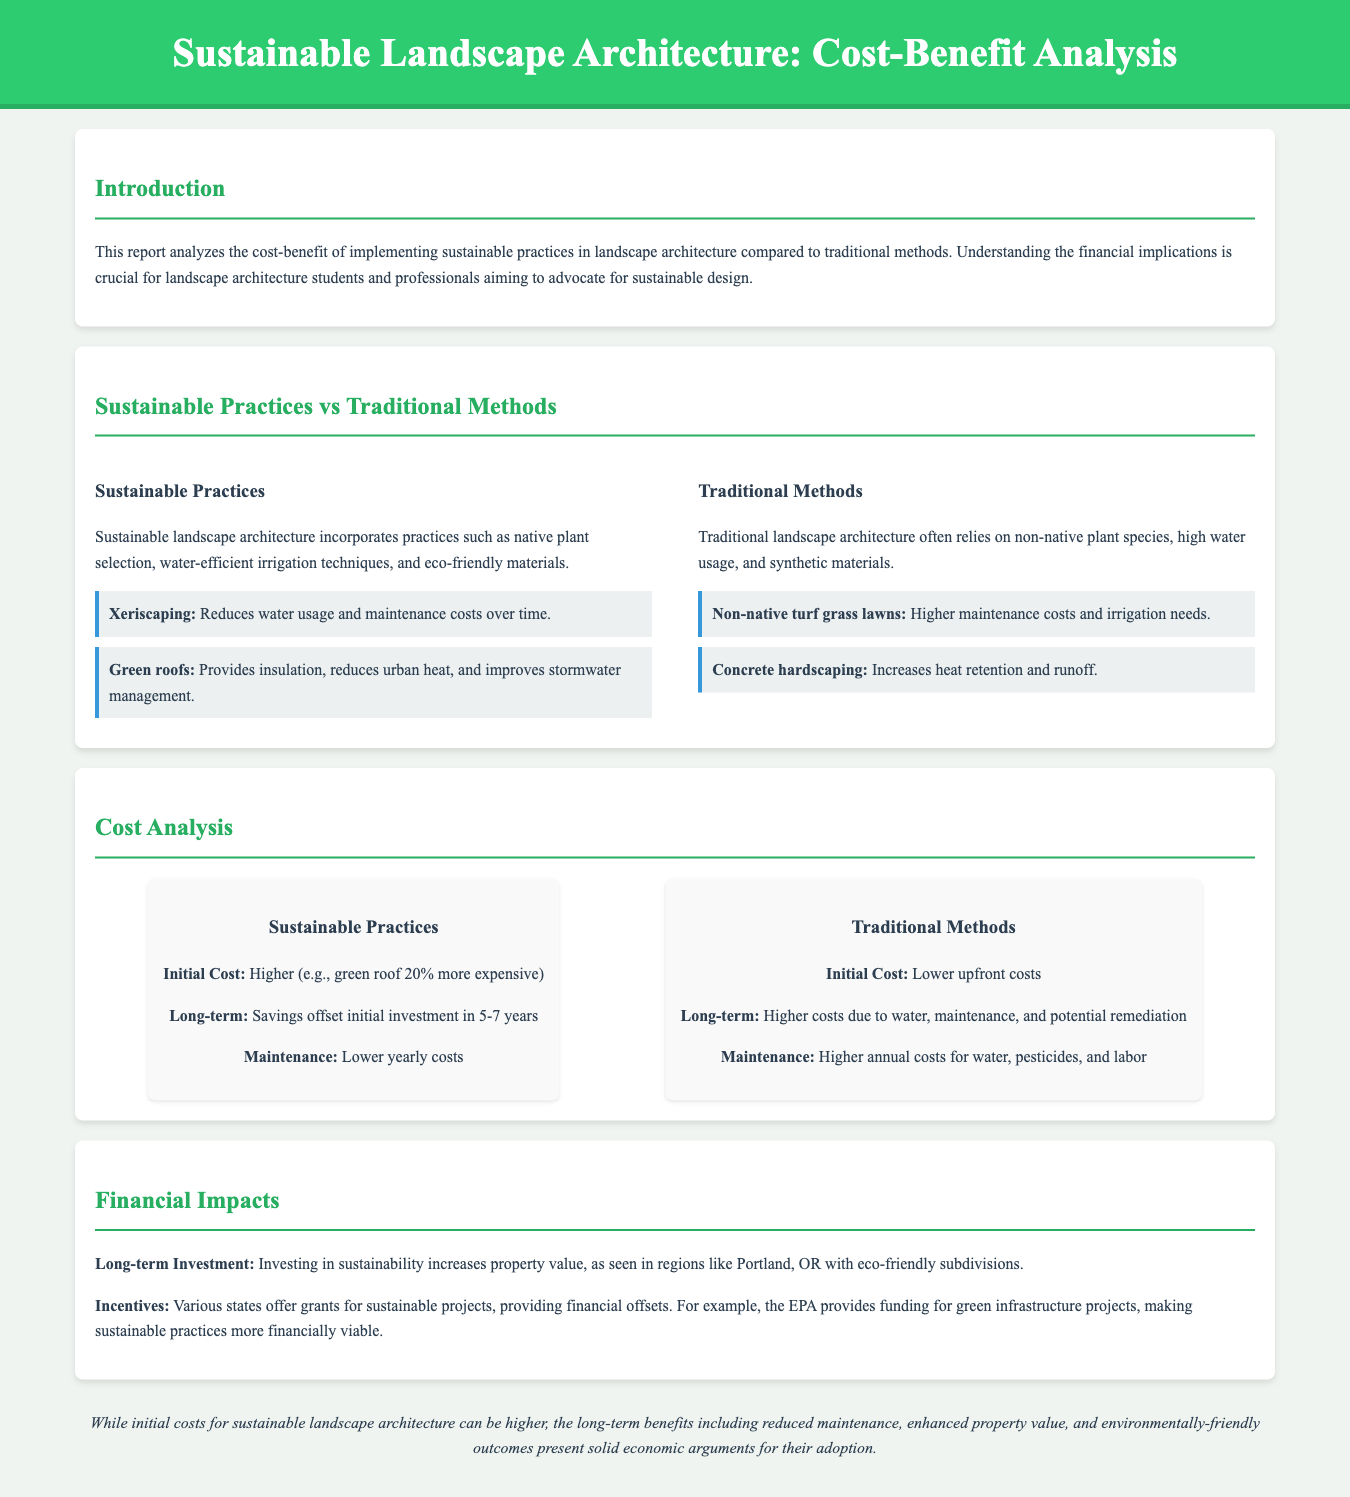What is the title of the report? The title of the report is highlighted in the header section of the document.
Answer: Sustainable Landscape Architecture: Cost-Benefit Analysis What practice reduces water usage and maintenance costs over time? The document provides examples of sustainable practices and specifically mentions xeriscaping as a solution to reduce water usage.
Answer: Xeriscaping What is the initial cost of sustainable practices compared to traditional methods? The cost analysis section describes the initial costs of sustainable practices as higher, specifically mentioning that green roofs are 20% more expensive.
Answer: Higher (20% more expensive) What time frame is mentioned for savings to offset the initial investment in sustainable practices? The report states that savings can offset the initial investment in a specific time period, which is crucial for understanding long-term impacts.
Answer: 5-7 years What is a financial incentive provided by the EPA for sustainable projects? The financial impacts section discusses various incentives, highlighting grants provided by the EPA for specific projects.
Answer: Funding for green infrastructure projects What is stated about property values in relation to sustainable investment? The document notes the impact of investing in sustainability on property values, offering a region-specific example.
Answer: Increases property value What are the maintenance costs for traditional methods described as? The cost analysis section describes the maintenance costs associated with traditional methods, contrasting with sustainable practices.
Answer: Higher annual costs What environmentally friendly outcome is mentioned in the conclusion? The conclusion summarizes the overall benefits of sustainable landscape architecture, including environmental outcomes.
Answer: Environmentally-friendly outcomes 